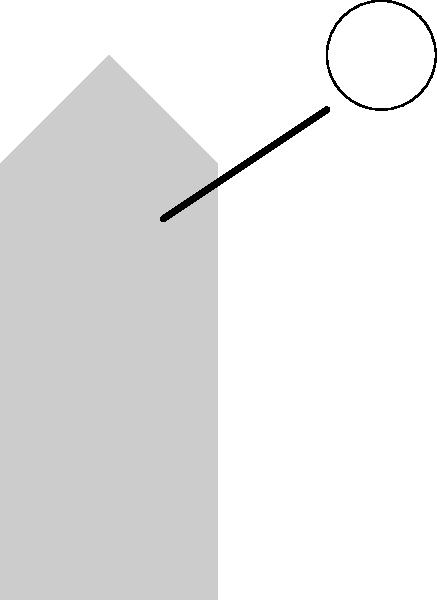A volleyball player is about to spike the ball. Using the free body diagram provided, which force vector represents the player's muscular effort to hit the ball, and what is its relationship to the other forces acting on the player's hand at the moment of impact? To analyze the force distribution in a volleyball spike using the free body diagram:

1. Identify the forces:
   - $F_{\text{hit}}$: The force applied to the ball (blue arrow pointing up and right)
   - $F_{\text{muscle}}$: The muscular force from the player (red arrow pointing down and left)
   - $F_{\text{gravity}}$: The gravitational force on the hand (green arrow pointing straight down)

2. Recognize the muscular effort:
   The red arrow ($F_{\text{muscle}}$) represents the player's muscular effort to hit the ball.

3. Analyze the relationships:
   - $F_{\text{muscle}}$ is opposite in direction to $F_{\text{hit}}$, indicating that the muscular force is what enables the player to strike the ball.
   - $F_{\text{muscle}}$ is larger in magnitude than $F_{\text{hit}}$, as it needs to overcome both the ball's resistance and gravity.
   - $F_{\text{gravity}}$ is perpendicular to both $F_{\text{hit}}$ and $F_{\text{muscle}}$, representing the constant downward pull on the hand.

4. Consider Newton's Third Law:
   The force applied to the ball ($F_{\text{hit}}$) is equal and opposite to the force the ball exerts on the hand.

5. Equilibrium condition:
   For the hand to move in the direction of the hit, the muscular force must be greater than the combined effects of the ball's resistance and gravity:

   $$\vec{F}_{\text{muscle}} > \vec{F}_{\text{hit}} + \vec{F}_{\text{gravity}}$$

In summary, the muscular force ($F_{\text{muscle}}$) is the primary active force, opposing and overcoming both the ball's resistance ($F_{\text{hit}}$) and gravity ($F_{\text{gravity}}$) to execute the spike successfully.
Answer: $F_{\text{muscle}}$ (red arrow); it opposes and exceeds $F_{\text{hit}}$ and $F_{\text{gravity}}$ combined. 